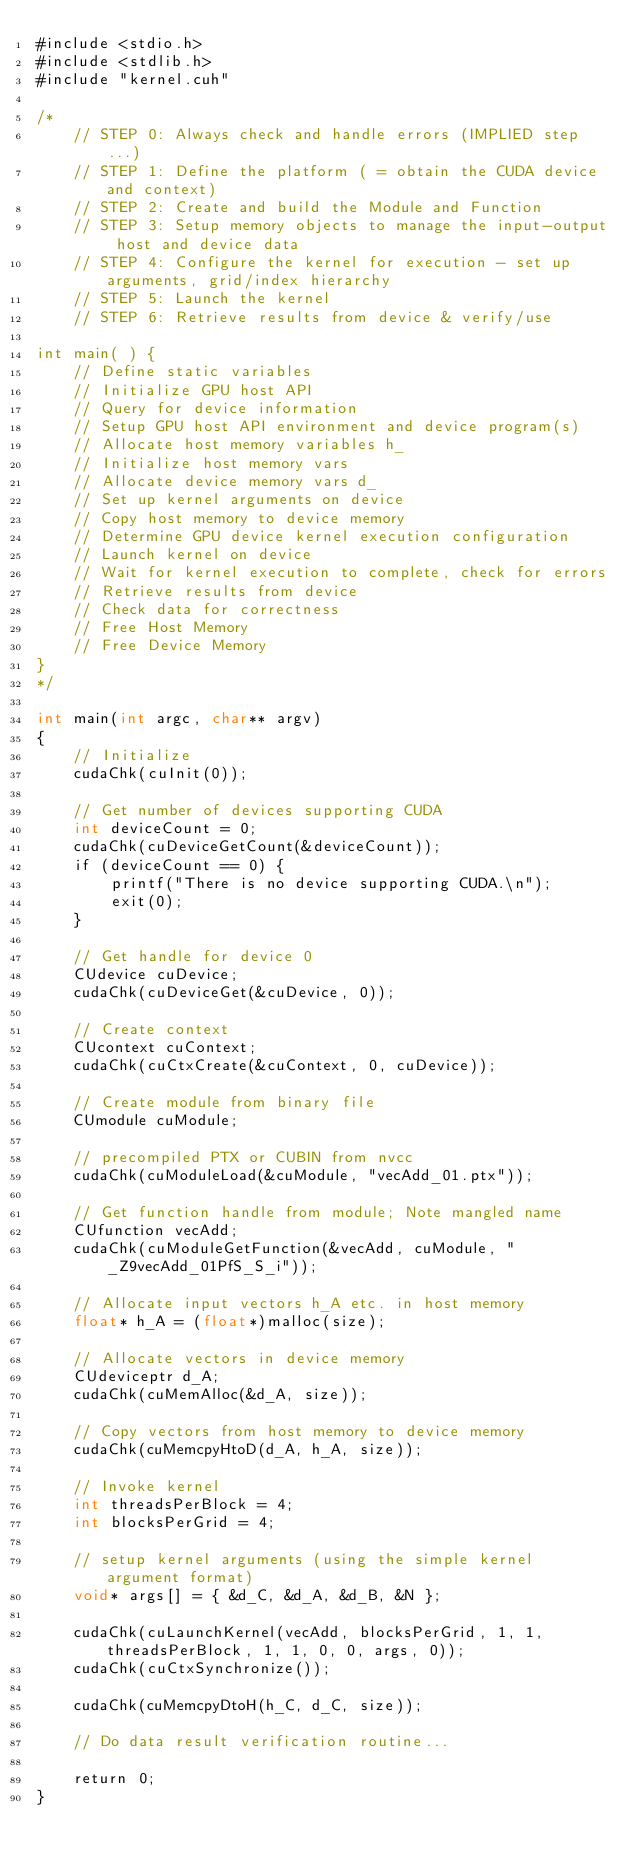<code> <loc_0><loc_0><loc_500><loc_500><_Cuda_>#include <stdio.h>
#include <stdlib.h>
#include "kernel.cuh"

/*
    // STEP 0: Always check and handle errors (IMPLIED step...)
    // STEP 1: Define the platform ( = obtain the CUDA device and context)
    // STEP 2: Create and build the Module and Function
    // STEP 3: Setup memory objects to manage the input-output host and device data
    // STEP 4: Configure the kernel for execution - set up arguments, grid/index hierarchy
    // STEP 5: Launch the kernel
    // STEP 6: Retrieve results from device & verify/use

int main( ) {
    // Define static variables
    // Initialize GPU host API
    // Query for device information
    // Setup GPU host API environment and device program(s)
    // Allocate host memory variables h_
    // Initialize host memory vars
    // Allocate device memory vars d_
    // Set up kernel arguments on device
    // Copy host memory to device memory
    // Determine GPU device kernel execution configuration
    // Launch kernel on device
    // Wait for kernel execution to complete, check for errors
    // Retrieve results from device
    // Check data for correctness
    // Free Host Memory
    // Free Device Memory
}
*/

int main(int argc, char** argv)
{ 
    // Initialize
    cudaChk(cuInit(0));
    
    // Get number of devices supporting CUDA
    int deviceCount = 0;
    cudaChk(cuDeviceGetCount(&deviceCount));
    if (deviceCount == 0) {
        printf("There is no device supporting CUDA.\n");
        exit(0);
    }

    // Get handle for device 0
    CUdevice cuDevice;
    cudaChk(cuDeviceGet(&cuDevice, 0));

    // Create context
    CUcontext cuContext;
    cudaChk(cuCtxCreate(&cuContext, 0, cuDevice));

    // Create module from binary file
    CUmodule cuModule;

    // precompiled PTX or CUBIN from nvcc
    cudaChk(cuModuleLoad(&cuModule, "vecAdd_01.ptx"));
    
    // Get function handle from module; Note mangled name
    CUfunction vecAdd;
    cudaChk(cuModuleGetFunction(&vecAdd, cuModule, "_Z9vecAdd_01PfS_S_i"));

    // Allocate input vectors h_A etc. in host memory
    float* h_A = (float*)malloc(size);

    // Allocate vectors in device memory
    CUdeviceptr d_A;
    cudaChk(cuMemAlloc(&d_A, size));

    // Copy vectors from host memory to device memory
    cudaChk(cuMemcpyHtoD(d_A, h_A, size));

    // Invoke kernel
    int threadsPerBlock = 4;
    int blocksPerGrid = 4;

    // setup kernel arguments (using the simple kernel argument format)
    void* args[] = { &d_C, &d_A, &d_B, &N };
    
    cudaChk(cuLaunchKernel(vecAdd, blocksPerGrid, 1, 1, threadsPerBlock, 1, 1, 0, 0, args, 0));
    cudaChk(cuCtxSynchronize());

    cudaChk(cuMemcpyDtoH(h_C, d_C, size));

    // Do data result verification routine...

    return 0;
}</code> 